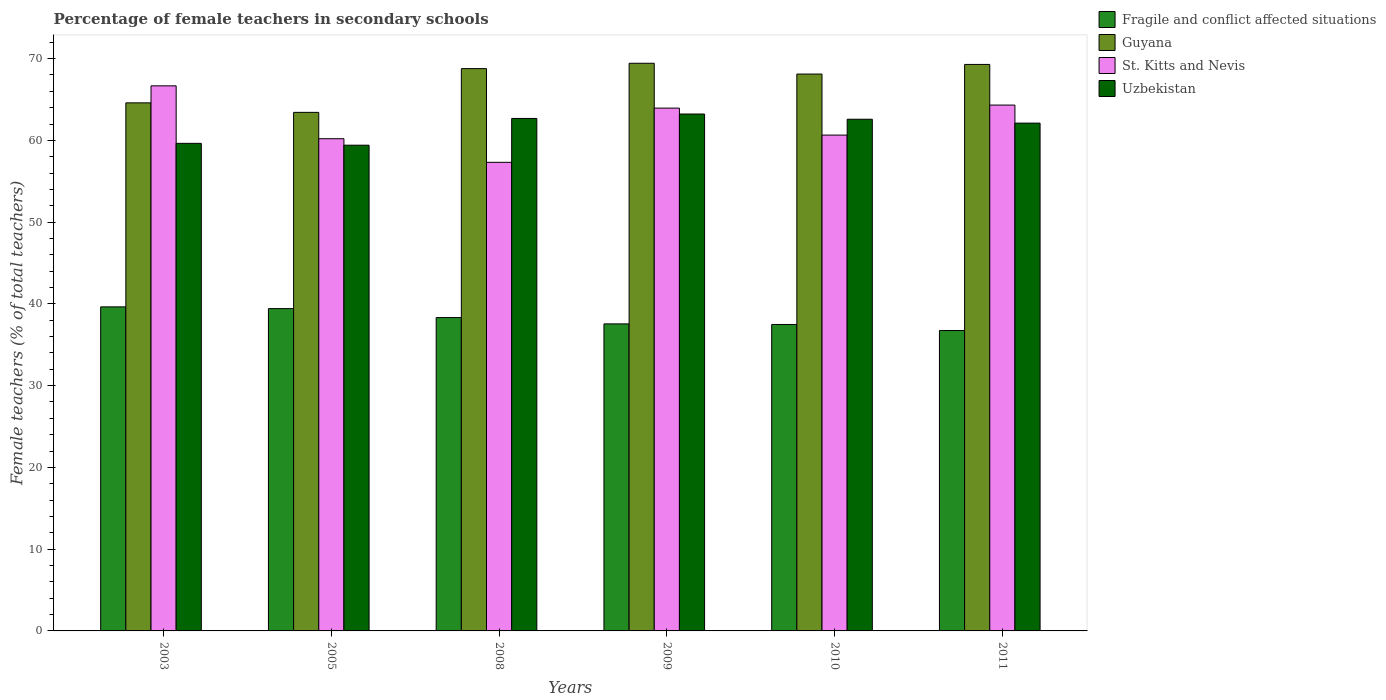How many groups of bars are there?
Your response must be concise. 6. Are the number of bars per tick equal to the number of legend labels?
Your response must be concise. Yes. Are the number of bars on each tick of the X-axis equal?
Provide a short and direct response. Yes. How many bars are there on the 3rd tick from the right?
Offer a very short reply. 4. What is the percentage of female teachers in St. Kitts and Nevis in 2008?
Make the answer very short. 57.31. Across all years, what is the maximum percentage of female teachers in Guyana?
Offer a terse response. 69.43. Across all years, what is the minimum percentage of female teachers in Fragile and conflict affected situations?
Your answer should be compact. 36.74. In which year was the percentage of female teachers in St. Kitts and Nevis minimum?
Keep it short and to the point. 2008. What is the total percentage of female teachers in St. Kitts and Nevis in the graph?
Provide a short and direct response. 373.09. What is the difference between the percentage of female teachers in St. Kitts and Nevis in 2005 and that in 2009?
Offer a very short reply. -3.74. What is the difference between the percentage of female teachers in Fragile and conflict affected situations in 2011 and the percentage of female teachers in St. Kitts and Nevis in 2008?
Your answer should be very brief. -20.57. What is the average percentage of female teachers in Fragile and conflict affected situations per year?
Provide a short and direct response. 38.19. In the year 2009, what is the difference between the percentage of female teachers in St. Kitts and Nevis and percentage of female teachers in Uzbekistan?
Provide a short and direct response. 0.73. In how many years, is the percentage of female teachers in Uzbekistan greater than 48 %?
Keep it short and to the point. 6. What is the ratio of the percentage of female teachers in Uzbekistan in 2003 to that in 2011?
Give a very brief answer. 0.96. Is the percentage of female teachers in Uzbekistan in 2003 less than that in 2009?
Your response must be concise. Yes. What is the difference between the highest and the second highest percentage of female teachers in Fragile and conflict affected situations?
Ensure brevity in your answer.  0.21. What is the difference between the highest and the lowest percentage of female teachers in St. Kitts and Nevis?
Your answer should be compact. 9.35. Is the sum of the percentage of female teachers in Guyana in 2005 and 2010 greater than the maximum percentage of female teachers in St. Kitts and Nevis across all years?
Offer a terse response. Yes. Is it the case that in every year, the sum of the percentage of female teachers in St. Kitts and Nevis and percentage of female teachers in Fragile and conflict affected situations is greater than the sum of percentage of female teachers in Uzbekistan and percentage of female teachers in Guyana?
Your answer should be very brief. No. What does the 2nd bar from the left in 2008 represents?
Your answer should be compact. Guyana. What does the 1st bar from the right in 2003 represents?
Make the answer very short. Uzbekistan. Is it the case that in every year, the sum of the percentage of female teachers in Guyana and percentage of female teachers in Fragile and conflict affected situations is greater than the percentage of female teachers in Uzbekistan?
Your answer should be very brief. Yes. Are all the bars in the graph horizontal?
Your answer should be compact. No. How many years are there in the graph?
Your answer should be compact. 6. Are the values on the major ticks of Y-axis written in scientific E-notation?
Make the answer very short. No. Does the graph contain grids?
Your answer should be very brief. No. How are the legend labels stacked?
Offer a very short reply. Vertical. What is the title of the graph?
Give a very brief answer. Percentage of female teachers in secondary schools. What is the label or title of the X-axis?
Your answer should be very brief. Years. What is the label or title of the Y-axis?
Your answer should be very brief. Female teachers (% of total teachers). What is the Female teachers (% of total teachers) of Fragile and conflict affected situations in 2003?
Offer a very short reply. 39.63. What is the Female teachers (% of total teachers) in Guyana in 2003?
Your answer should be compact. 64.59. What is the Female teachers (% of total teachers) in St. Kitts and Nevis in 2003?
Ensure brevity in your answer.  66.67. What is the Female teachers (% of total teachers) in Uzbekistan in 2003?
Make the answer very short. 59.63. What is the Female teachers (% of total teachers) of Fragile and conflict affected situations in 2005?
Ensure brevity in your answer.  39.42. What is the Female teachers (% of total teachers) of Guyana in 2005?
Give a very brief answer. 63.42. What is the Female teachers (% of total teachers) in St. Kitts and Nevis in 2005?
Offer a terse response. 60.2. What is the Female teachers (% of total teachers) in Uzbekistan in 2005?
Your response must be concise. 59.41. What is the Female teachers (% of total teachers) of Fragile and conflict affected situations in 2008?
Offer a very short reply. 38.33. What is the Female teachers (% of total teachers) of Guyana in 2008?
Provide a succinct answer. 68.77. What is the Female teachers (% of total teachers) in St. Kitts and Nevis in 2008?
Give a very brief answer. 57.31. What is the Female teachers (% of total teachers) in Uzbekistan in 2008?
Give a very brief answer. 62.68. What is the Female teachers (% of total teachers) of Fragile and conflict affected situations in 2009?
Your answer should be compact. 37.55. What is the Female teachers (% of total teachers) in Guyana in 2009?
Your response must be concise. 69.43. What is the Female teachers (% of total teachers) of St. Kitts and Nevis in 2009?
Offer a terse response. 63.95. What is the Female teachers (% of total teachers) in Uzbekistan in 2009?
Your answer should be very brief. 63.22. What is the Female teachers (% of total teachers) in Fragile and conflict affected situations in 2010?
Ensure brevity in your answer.  37.48. What is the Female teachers (% of total teachers) of Guyana in 2010?
Keep it short and to the point. 68.11. What is the Female teachers (% of total teachers) of St. Kitts and Nevis in 2010?
Ensure brevity in your answer.  60.65. What is the Female teachers (% of total teachers) of Uzbekistan in 2010?
Provide a succinct answer. 62.58. What is the Female teachers (% of total teachers) in Fragile and conflict affected situations in 2011?
Offer a terse response. 36.74. What is the Female teachers (% of total teachers) of Guyana in 2011?
Your answer should be very brief. 69.29. What is the Female teachers (% of total teachers) in St. Kitts and Nevis in 2011?
Keep it short and to the point. 64.32. What is the Female teachers (% of total teachers) in Uzbekistan in 2011?
Your response must be concise. 62.11. Across all years, what is the maximum Female teachers (% of total teachers) in Fragile and conflict affected situations?
Keep it short and to the point. 39.63. Across all years, what is the maximum Female teachers (% of total teachers) in Guyana?
Keep it short and to the point. 69.43. Across all years, what is the maximum Female teachers (% of total teachers) in St. Kitts and Nevis?
Give a very brief answer. 66.67. Across all years, what is the maximum Female teachers (% of total teachers) of Uzbekistan?
Ensure brevity in your answer.  63.22. Across all years, what is the minimum Female teachers (% of total teachers) in Fragile and conflict affected situations?
Your answer should be very brief. 36.74. Across all years, what is the minimum Female teachers (% of total teachers) of Guyana?
Provide a short and direct response. 63.42. Across all years, what is the minimum Female teachers (% of total teachers) in St. Kitts and Nevis?
Provide a succinct answer. 57.31. Across all years, what is the minimum Female teachers (% of total teachers) of Uzbekistan?
Make the answer very short. 59.41. What is the total Female teachers (% of total teachers) of Fragile and conflict affected situations in the graph?
Keep it short and to the point. 229.15. What is the total Female teachers (% of total teachers) in Guyana in the graph?
Make the answer very short. 403.61. What is the total Female teachers (% of total teachers) of St. Kitts and Nevis in the graph?
Your answer should be compact. 373.09. What is the total Female teachers (% of total teachers) in Uzbekistan in the graph?
Offer a very short reply. 369.63. What is the difference between the Female teachers (% of total teachers) of Fragile and conflict affected situations in 2003 and that in 2005?
Make the answer very short. 0.21. What is the difference between the Female teachers (% of total teachers) of Guyana in 2003 and that in 2005?
Make the answer very short. 1.16. What is the difference between the Female teachers (% of total teachers) in St. Kitts and Nevis in 2003 and that in 2005?
Your response must be concise. 6.47. What is the difference between the Female teachers (% of total teachers) in Uzbekistan in 2003 and that in 2005?
Give a very brief answer. 0.22. What is the difference between the Female teachers (% of total teachers) of Fragile and conflict affected situations in 2003 and that in 2008?
Your response must be concise. 1.31. What is the difference between the Female teachers (% of total teachers) of Guyana in 2003 and that in 2008?
Offer a very short reply. -4.19. What is the difference between the Female teachers (% of total teachers) of St. Kitts and Nevis in 2003 and that in 2008?
Ensure brevity in your answer.  9.35. What is the difference between the Female teachers (% of total teachers) of Uzbekistan in 2003 and that in 2008?
Make the answer very short. -3.04. What is the difference between the Female teachers (% of total teachers) of Fragile and conflict affected situations in 2003 and that in 2009?
Give a very brief answer. 2.08. What is the difference between the Female teachers (% of total teachers) in Guyana in 2003 and that in 2009?
Ensure brevity in your answer.  -4.84. What is the difference between the Female teachers (% of total teachers) of St. Kitts and Nevis in 2003 and that in 2009?
Your response must be concise. 2.72. What is the difference between the Female teachers (% of total teachers) of Uzbekistan in 2003 and that in 2009?
Your answer should be compact. -3.59. What is the difference between the Female teachers (% of total teachers) in Fragile and conflict affected situations in 2003 and that in 2010?
Your answer should be compact. 2.15. What is the difference between the Female teachers (% of total teachers) in Guyana in 2003 and that in 2010?
Offer a very short reply. -3.52. What is the difference between the Female teachers (% of total teachers) in St. Kitts and Nevis in 2003 and that in 2010?
Keep it short and to the point. 6.02. What is the difference between the Female teachers (% of total teachers) of Uzbekistan in 2003 and that in 2010?
Your answer should be very brief. -2.95. What is the difference between the Female teachers (% of total teachers) in Fragile and conflict affected situations in 2003 and that in 2011?
Give a very brief answer. 2.89. What is the difference between the Female teachers (% of total teachers) in Guyana in 2003 and that in 2011?
Your answer should be very brief. -4.7. What is the difference between the Female teachers (% of total teachers) of St. Kitts and Nevis in 2003 and that in 2011?
Offer a terse response. 2.35. What is the difference between the Female teachers (% of total teachers) in Uzbekistan in 2003 and that in 2011?
Keep it short and to the point. -2.47. What is the difference between the Female teachers (% of total teachers) of Fragile and conflict affected situations in 2005 and that in 2008?
Your answer should be compact. 1.09. What is the difference between the Female teachers (% of total teachers) in Guyana in 2005 and that in 2008?
Keep it short and to the point. -5.35. What is the difference between the Female teachers (% of total teachers) in St. Kitts and Nevis in 2005 and that in 2008?
Provide a succinct answer. 2.89. What is the difference between the Female teachers (% of total teachers) of Uzbekistan in 2005 and that in 2008?
Give a very brief answer. -3.27. What is the difference between the Female teachers (% of total teachers) in Fragile and conflict affected situations in 2005 and that in 2009?
Ensure brevity in your answer.  1.87. What is the difference between the Female teachers (% of total teachers) of Guyana in 2005 and that in 2009?
Your answer should be compact. -6.01. What is the difference between the Female teachers (% of total teachers) of St. Kitts and Nevis in 2005 and that in 2009?
Ensure brevity in your answer.  -3.74. What is the difference between the Female teachers (% of total teachers) in Uzbekistan in 2005 and that in 2009?
Make the answer very short. -3.81. What is the difference between the Female teachers (% of total teachers) in Fragile and conflict affected situations in 2005 and that in 2010?
Provide a succinct answer. 1.94. What is the difference between the Female teachers (% of total teachers) in Guyana in 2005 and that in 2010?
Keep it short and to the point. -4.69. What is the difference between the Female teachers (% of total teachers) of St. Kitts and Nevis in 2005 and that in 2010?
Make the answer very short. -0.44. What is the difference between the Female teachers (% of total teachers) in Uzbekistan in 2005 and that in 2010?
Your answer should be compact. -3.17. What is the difference between the Female teachers (% of total teachers) in Fragile and conflict affected situations in 2005 and that in 2011?
Your response must be concise. 2.68. What is the difference between the Female teachers (% of total teachers) in Guyana in 2005 and that in 2011?
Offer a terse response. -5.86. What is the difference between the Female teachers (% of total teachers) of St. Kitts and Nevis in 2005 and that in 2011?
Your answer should be compact. -4.11. What is the difference between the Female teachers (% of total teachers) in Uzbekistan in 2005 and that in 2011?
Your answer should be compact. -2.7. What is the difference between the Female teachers (% of total teachers) of Fragile and conflict affected situations in 2008 and that in 2009?
Keep it short and to the point. 0.77. What is the difference between the Female teachers (% of total teachers) of Guyana in 2008 and that in 2009?
Offer a very short reply. -0.66. What is the difference between the Female teachers (% of total teachers) of St. Kitts and Nevis in 2008 and that in 2009?
Offer a terse response. -6.63. What is the difference between the Female teachers (% of total teachers) in Uzbekistan in 2008 and that in 2009?
Provide a short and direct response. -0.54. What is the difference between the Female teachers (% of total teachers) in Fragile and conflict affected situations in 2008 and that in 2010?
Provide a short and direct response. 0.84. What is the difference between the Female teachers (% of total teachers) in Guyana in 2008 and that in 2010?
Your response must be concise. 0.67. What is the difference between the Female teachers (% of total teachers) of St. Kitts and Nevis in 2008 and that in 2010?
Your answer should be very brief. -3.33. What is the difference between the Female teachers (% of total teachers) in Uzbekistan in 2008 and that in 2010?
Make the answer very short. 0.09. What is the difference between the Female teachers (% of total teachers) of Fragile and conflict affected situations in 2008 and that in 2011?
Provide a succinct answer. 1.58. What is the difference between the Female teachers (% of total teachers) of Guyana in 2008 and that in 2011?
Your answer should be very brief. -0.51. What is the difference between the Female teachers (% of total teachers) of St. Kitts and Nevis in 2008 and that in 2011?
Make the answer very short. -7. What is the difference between the Female teachers (% of total teachers) of Uzbekistan in 2008 and that in 2011?
Your answer should be very brief. 0.57. What is the difference between the Female teachers (% of total teachers) of Fragile and conflict affected situations in 2009 and that in 2010?
Give a very brief answer. 0.07. What is the difference between the Female teachers (% of total teachers) of Guyana in 2009 and that in 2010?
Provide a short and direct response. 1.32. What is the difference between the Female teachers (% of total teachers) of St. Kitts and Nevis in 2009 and that in 2010?
Give a very brief answer. 3.3. What is the difference between the Female teachers (% of total teachers) in Uzbekistan in 2009 and that in 2010?
Ensure brevity in your answer.  0.64. What is the difference between the Female teachers (% of total teachers) in Fragile and conflict affected situations in 2009 and that in 2011?
Your answer should be very brief. 0.81. What is the difference between the Female teachers (% of total teachers) of Guyana in 2009 and that in 2011?
Your answer should be very brief. 0.14. What is the difference between the Female teachers (% of total teachers) of St. Kitts and Nevis in 2009 and that in 2011?
Give a very brief answer. -0.37. What is the difference between the Female teachers (% of total teachers) of Uzbekistan in 2009 and that in 2011?
Make the answer very short. 1.11. What is the difference between the Female teachers (% of total teachers) in Fragile and conflict affected situations in 2010 and that in 2011?
Provide a short and direct response. 0.74. What is the difference between the Female teachers (% of total teachers) in Guyana in 2010 and that in 2011?
Your answer should be compact. -1.18. What is the difference between the Female teachers (% of total teachers) in St. Kitts and Nevis in 2010 and that in 2011?
Keep it short and to the point. -3.67. What is the difference between the Female teachers (% of total teachers) in Uzbekistan in 2010 and that in 2011?
Give a very brief answer. 0.47. What is the difference between the Female teachers (% of total teachers) in Fragile and conflict affected situations in 2003 and the Female teachers (% of total teachers) in Guyana in 2005?
Offer a very short reply. -23.79. What is the difference between the Female teachers (% of total teachers) of Fragile and conflict affected situations in 2003 and the Female teachers (% of total teachers) of St. Kitts and Nevis in 2005?
Give a very brief answer. -20.57. What is the difference between the Female teachers (% of total teachers) in Fragile and conflict affected situations in 2003 and the Female teachers (% of total teachers) in Uzbekistan in 2005?
Provide a succinct answer. -19.77. What is the difference between the Female teachers (% of total teachers) in Guyana in 2003 and the Female teachers (% of total teachers) in St. Kitts and Nevis in 2005?
Offer a terse response. 4.38. What is the difference between the Female teachers (% of total teachers) in Guyana in 2003 and the Female teachers (% of total teachers) in Uzbekistan in 2005?
Make the answer very short. 5.18. What is the difference between the Female teachers (% of total teachers) of St. Kitts and Nevis in 2003 and the Female teachers (% of total teachers) of Uzbekistan in 2005?
Make the answer very short. 7.26. What is the difference between the Female teachers (% of total teachers) of Fragile and conflict affected situations in 2003 and the Female teachers (% of total teachers) of Guyana in 2008?
Make the answer very short. -29.14. What is the difference between the Female teachers (% of total teachers) in Fragile and conflict affected situations in 2003 and the Female teachers (% of total teachers) in St. Kitts and Nevis in 2008?
Ensure brevity in your answer.  -17.68. What is the difference between the Female teachers (% of total teachers) in Fragile and conflict affected situations in 2003 and the Female teachers (% of total teachers) in Uzbekistan in 2008?
Your answer should be very brief. -23.04. What is the difference between the Female teachers (% of total teachers) of Guyana in 2003 and the Female teachers (% of total teachers) of St. Kitts and Nevis in 2008?
Ensure brevity in your answer.  7.27. What is the difference between the Female teachers (% of total teachers) in Guyana in 2003 and the Female teachers (% of total teachers) in Uzbekistan in 2008?
Offer a very short reply. 1.91. What is the difference between the Female teachers (% of total teachers) in St. Kitts and Nevis in 2003 and the Female teachers (% of total teachers) in Uzbekistan in 2008?
Make the answer very short. 3.99. What is the difference between the Female teachers (% of total teachers) of Fragile and conflict affected situations in 2003 and the Female teachers (% of total teachers) of Guyana in 2009?
Keep it short and to the point. -29.8. What is the difference between the Female teachers (% of total teachers) in Fragile and conflict affected situations in 2003 and the Female teachers (% of total teachers) in St. Kitts and Nevis in 2009?
Provide a short and direct response. -24.31. What is the difference between the Female teachers (% of total teachers) of Fragile and conflict affected situations in 2003 and the Female teachers (% of total teachers) of Uzbekistan in 2009?
Give a very brief answer. -23.59. What is the difference between the Female teachers (% of total teachers) of Guyana in 2003 and the Female teachers (% of total teachers) of St. Kitts and Nevis in 2009?
Provide a succinct answer. 0.64. What is the difference between the Female teachers (% of total teachers) in Guyana in 2003 and the Female teachers (% of total teachers) in Uzbekistan in 2009?
Give a very brief answer. 1.37. What is the difference between the Female teachers (% of total teachers) in St. Kitts and Nevis in 2003 and the Female teachers (% of total teachers) in Uzbekistan in 2009?
Make the answer very short. 3.45. What is the difference between the Female teachers (% of total teachers) in Fragile and conflict affected situations in 2003 and the Female teachers (% of total teachers) in Guyana in 2010?
Your response must be concise. -28.48. What is the difference between the Female teachers (% of total teachers) in Fragile and conflict affected situations in 2003 and the Female teachers (% of total teachers) in St. Kitts and Nevis in 2010?
Ensure brevity in your answer.  -21.01. What is the difference between the Female teachers (% of total teachers) in Fragile and conflict affected situations in 2003 and the Female teachers (% of total teachers) in Uzbekistan in 2010?
Keep it short and to the point. -22.95. What is the difference between the Female teachers (% of total teachers) of Guyana in 2003 and the Female teachers (% of total teachers) of St. Kitts and Nevis in 2010?
Provide a succinct answer. 3.94. What is the difference between the Female teachers (% of total teachers) in Guyana in 2003 and the Female teachers (% of total teachers) in Uzbekistan in 2010?
Provide a short and direct response. 2. What is the difference between the Female teachers (% of total teachers) of St. Kitts and Nevis in 2003 and the Female teachers (% of total teachers) of Uzbekistan in 2010?
Your answer should be compact. 4.08. What is the difference between the Female teachers (% of total teachers) in Fragile and conflict affected situations in 2003 and the Female teachers (% of total teachers) in Guyana in 2011?
Keep it short and to the point. -29.65. What is the difference between the Female teachers (% of total teachers) of Fragile and conflict affected situations in 2003 and the Female teachers (% of total teachers) of St. Kitts and Nevis in 2011?
Your answer should be very brief. -24.68. What is the difference between the Female teachers (% of total teachers) of Fragile and conflict affected situations in 2003 and the Female teachers (% of total teachers) of Uzbekistan in 2011?
Offer a terse response. -22.47. What is the difference between the Female teachers (% of total teachers) in Guyana in 2003 and the Female teachers (% of total teachers) in St. Kitts and Nevis in 2011?
Your answer should be very brief. 0.27. What is the difference between the Female teachers (% of total teachers) of Guyana in 2003 and the Female teachers (% of total teachers) of Uzbekistan in 2011?
Your answer should be compact. 2.48. What is the difference between the Female teachers (% of total teachers) of St. Kitts and Nevis in 2003 and the Female teachers (% of total teachers) of Uzbekistan in 2011?
Your answer should be very brief. 4.56. What is the difference between the Female teachers (% of total teachers) of Fragile and conflict affected situations in 2005 and the Female teachers (% of total teachers) of Guyana in 2008?
Give a very brief answer. -29.35. What is the difference between the Female teachers (% of total teachers) of Fragile and conflict affected situations in 2005 and the Female teachers (% of total teachers) of St. Kitts and Nevis in 2008?
Offer a terse response. -17.89. What is the difference between the Female teachers (% of total teachers) of Fragile and conflict affected situations in 2005 and the Female teachers (% of total teachers) of Uzbekistan in 2008?
Provide a succinct answer. -23.26. What is the difference between the Female teachers (% of total teachers) of Guyana in 2005 and the Female teachers (% of total teachers) of St. Kitts and Nevis in 2008?
Give a very brief answer. 6.11. What is the difference between the Female teachers (% of total teachers) of Guyana in 2005 and the Female teachers (% of total teachers) of Uzbekistan in 2008?
Provide a short and direct response. 0.75. What is the difference between the Female teachers (% of total teachers) in St. Kitts and Nevis in 2005 and the Female teachers (% of total teachers) in Uzbekistan in 2008?
Give a very brief answer. -2.48. What is the difference between the Female teachers (% of total teachers) of Fragile and conflict affected situations in 2005 and the Female teachers (% of total teachers) of Guyana in 2009?
Keep it short and to the point. -30.01. What is the difference between the Female teachers (% of total teachers) in Fragile and conflict affected situations in 2005 and the Female teachers (% of total teachers) in St. Kitts and Nevis in 2009?
Make the answer very short. -24.52. What is the difference between the Female teachers (% of total teachers) in Fragile and conflict affected situations in 2005 and the Female teachers (% of total teachers) in Uzbekistan in 2009?
Your answer should be very brief. -23.8. What is the difference between the Female teachers (% of total teachers) in Guyana in 2005 and the Female teachers (% of total teachers) in St. Kitts and Nevis in 2009?
Your answer should be very brief. -0.52. What is the difference between the Female teachers (% of total teachers) in Guyana in 2005 and the Female teachers (% of total teachers) in Uzbekistan in 2009?
Your answer should be compact. 0.2. What is the difference between the Female teachers (% of total teachers) in St. Kitts and Nevis in 2005 and the Female teachers (% of total teachers) in Uzbekistan in 2009?
Make the answer very short. -3.02. What is the difference between the Female teachers (% of total teachers) of Fragile and conflict affected situations in 2005 and the Female teachers (% of total teachers) of Guyana in 2010?
Provide a short and direct response. -28.69. What is the difference between the Female teachers (% of total teachers) in Fragile and conflict affected situations in 2005 and the Female teachers (% of total teachers) in St. Kitts and Nevis in 2010?
Your answer should be very brief. -21.22. What is the difference between the Female teachers (% of total teachers) in Fragile and conflict affected situations in 2005 and the Female teachers (% of total teachers) in Uzbekistan in 2010?
Keep it short and to the point. -23.16. What is the difference between the Female teachers (% of total teachers) of Guyana in 2005 and the Female teachers (% of total teachers) of St. Kitts and Nevis in 2010?
Provide a short and direct response. 2.78. What is the difference between the Female teachers (% of total teachers) of Guyana in 2005 and the Female teachers (% of total teachers) of Uzbekistan in 2010?
Your response must be concise. 0.84. What is the difference between the Female teachers (% of total teachers) in St. Kitts and Nevis in 2005 and the Female teachers (% of total teachers) in Uzbekistan in 2010?
Provide a succinct answer. -2.38. What is the difference between the Female teachers (% of total teachers) of Fragile and conflict affected situations in 2005 and the Female teachers (% of total teachers) of Guyana in 2011?
Your answer should be compact. -29.87. What is the difference between the Female teachers (% of total teachers) of Fragile and conflict affected situations in 2005 and the Female teachers (% of total teachers) of St. Kitts and Nevis in 2011?
Provide a short and direct response. -24.9. What is the difference between the Female teachers (% of total teachers) in Fragile and conflict affected situations in 2005 and the Female teachers (% of total teachers) in Uzbekistan in 2011?
Your response must be concise. -22.69. What is the difference between the Female teachers (% of total teachers) of Guyana in 2005 and the Female teachers (% of total teachers) of St. Kitts and Nevis in 2011?
Offer a terse response. -0.89. What is the difference between the Female teachers (% of total teachers) in Guyana in 2005 and the Female teachers (% of total teachers) in Uzbekistan in 2011?
Offer a terse response. 1.31. What is the difference between the Female teachers (% of total teachers) of St. Kitts and Nevis in 2005 and the Female teachers (% of total teachers) of Uzbekistan in 2011?
Your answer should be compact. -1.91. What is the difference between the Female teachers (% of total teachers) of Fragile and conflict affected situations in 2008 and the Female teachers (% of total teachers) of Guyana in 2009?
Ensure brevity in your answer.  -31.1. What is the difference between the Female teachers (% of total teachers) of Fragile and conflict affected situations in 2008 and the Female teachers (% of total teachers) of St. Kitts and Nevis in 2009?
Ensure brevity in your answer.  -25.62. What is the difference between the Female teachers (% of total teachers) of Fragile and conflict affected situations in 2008 and the Female teachers (% of total teachers) of Uzbekistan in 2009?
Ensure brevity in your answer.  -24.89. What is the difference between the Female teachers (% of total teachers) of Guyana in 2008 and the Female teachers (% of total teachers) of St. Kitts and Nevis in 2009?
Ensure brevity in your answer.  4.83. What is the difference between the Female teachers (% of total teachers) in Guyana in 2008 and the Female teachers (% of total teachers) in Uzbekistan in 2009?
Make the answer very short. 5.55. What is the difference between the Female teachers (% of total teachers) in St. Kitts and Nevis in 2008 and the Female teachers (% of total teachers) in Uzbekistan in 2009?
Offer a very short reply. -5.91. What is the difference between the Female teachers (% of total teachers) in Fragile and conflict affected situations in 2008 and the Female teachers (% of total teachers) in Guyana in 2010?
Make the answer very short. -29.78. What is the difference between the Female teachers (% of total teachers) in Fragile and conflict affected situations in 2008 and the Female teachers (% of total teachers) in St. Kitts and Nevis in 2010?
Keep it short and to the point. -22.32. What is the difference between the Female teachers (% of total teachers) of Fragile and conflict affected situations in 2008 and the Female teachers (% of total teachers) of Uzbekistan in 2010?
Your response must be concise. -24.26. What is the difference between the Female teachers (% of total teachers) in Guyana in 2008 and the Female teachers (% of total teachers) in St. Kitts and Nevis in 2010?
Offer a terse response. 8.13. What is the difference between the Female teachers (% of total teachers) in Guyana in 2008 and the Female teachers (% of total teachers) in Uzbekistan in 2010?
Offer a very short reply. 6.19. What is the difference between the Female teachers (% of total teachers) of St. Kitts and Nevis in 2008 and the Female teachers (% of total teachers) of Uzbekistan in 2010?
Provide a short and direct response. -5.27. What is the difference between the Female teachers (% of total teachers) of Fragile and conflict affected situations in 2008 and the Female teachers (% of total teachers) of Guyana in 2011?
Your answer should be very brief. -30.96. What is the difference between the Female teachers (% of total teachers) of Fragile and conflict affected situations in 2008 and the Female teachers (% of total teachers) of St. Kitts and Nevis in 2011?
Your answer should be very brief. -25.99. What is the difference between the Female teachers (% of total teachers) of Fragile and conflict affected situations in 2008 and the Female teachers (% of total teachers) of Uzbekistan in 2011?
Give a very brief answer. -23.78. What is the difference between the Female teachers (% of total teachers) of Guyana in 2008 and the Female teachers (% of total teachers) of St. Kitts and Nevis in 2011?
Your answer should be very brief. 4.46. What is the difference between the Female teachers (% of total teachers) of Guyana in 2008 and the Female teachers (% of total teachers) of Uzbekistan in 2011?
Your response must be concise. 6.67. What is the difference between the Female teachers (% of total teachers) in St. Kitts and Nevis in 2008 and the Female teachers (% of total teachers) in Uzbekistan in 2011?
Your answer should be very brief. -4.79. What is the difference between the Female teachers (% of total teachers) of Fragile and conflict affected situations in 2009 and the Female teachers (% of total teachers) of Guyana in 2010?
Offer a very short reply. -30.56. What is the difference between the Female teachers (% of total teachers) of Fragile and conflict affected situations in 2009 and the Female teachers (% of total teachers) of St. Kitts and Nevis in 2010?
Your response must be concise. -23.09. What is the difference between the Female teachers (% of total teachers) of Fragile and conflict affected situations in 2009 and the Female teachers (% of total teachers) of Uzbekistan in 2010?
Offer a terse response. -25.03. What is the difference between the Female teachers (% of total teachers) in Guyana in 2009 and the Female teachers (% of total teachers) in St. Kitts and Nevis in 2010?
Your response must be concise. 8.78. What is the difference between the Female teachers (% of total teachers) in Guyana in 2009 and the Female teachers (% of total teachers) in Uzbekistan in 2010?
Keep it short and to the point. 6.85. What is the difference between the Female teachers (% of total teachers) of St. Kitts and Nevis in 2009 and the Female teachers (% of total teachers) of Uzbekistan in 2010?
Keep it short and to the point. 1.36. What is the difference between the Female teachers (% of total teachers) of Fragile and conflict affected situations in 2009 and the Female teachers (% of total teachers) of Guyana in 2011?
Your response must be concise. -31.73. What is the difference between the Female teachers (% of total teachers) of Fragile and conflict affected situations in 2009 and the Female teachers (% of total teachers) of St. Kitts and Nevis in 2011?
Your answer should be compact. -26.76. What is the difference between the Female teachers (% of total teachers) of Fragile and conflict affected situations in 2009 and the Female teachers (% of total teachers) of Uzbekistan in 2011?
Ensure brevity in your answer.  -24.56. What is the difference between the Female teachers (% of total teachers) of Guyana in 2009 and the Female teachers (% of total teachers) of St. Kitts and Nevis in 2011?
Your answer should be very brief. 5.11. What is the difference between the Female teachers (% of total teachers) of Guyana in 2009 and the Female teachers (% of total teachers) of Uzbekistan in 2011?
Offer a very short reply. 7.32. What is the difference between the Female teachers (% of total teachers) of St. Kitts and Nevis in 2009 and the Female teachers (% of total teachers) of Uzbekistan in 2011?
Your response must be concise. 1.84. What is the difference between the Female teachers (% of total teachers) of Fragile and conflict affected situations in 2010 and the Female teachers (% of total teachers) of Guyana in 2011?
Your answer should be very brief. -31.81. What is the difference between the Female teachers (% of total teachers) of Fragile and conflict affected situations in 2010 and the Female teachers (% of total teachers) of St. Kitts and Nevis in 2011?
Provide a short and direct response. -26.84. What is the difference between the Female teachers (% of total teachers) of Fragile and conflict affected situations in 2010 and the Female teachers (% of total teachers) of Uzbekistan in 2011?
Provide a succinct answer. -24.63. What is the difference between the Female teachers (% of total teachers) of Guyana in 2010 and the Female teachers (% of total teachers) of St. Kitts and Nevis in 2011?
Provide a short and direct response. 3.79. What is the difference between the Female teachers (% of total teachers) of Guyana in 2010 and the Female teachers (% of total teachers) of Uzbekistan in 2011?
Your answer should be very brief. 6. What is the difference between the Female teachers (% of total teachers) of St. Kitts and Nevis in 2010 and the Female teachers (% of total teachers) of Uzbekistan in 2011?
Give a very brief answer. -1.46. What is the average Female teachers (% of total teachers) in Fragile and conflict affected situations per year?
Ensure brevity in your answer.  38.19. What is the average Female teachers (% of total teachers) in Guyana per year?
Keep it short and to the point. 67.27. What is the average Female teachers (% of total teachers) in St. Kitts and Nevis per year?
Your answer should be very brief. 62.18. What is the average Female teachers (% of total teachers) in Uzbekistan per year?
Your answer should be very brief. 61.6. In the year 2003, what is the difference between the Female teachers (% of total teachers) in Fragile and conflict affected situations and Female teachers (% of total teachers) in Guyana?
Keep it short and to the point. -24.95. In the year 2003, what is the difference between the Female teachers (% of total teachers) of Fragile and conflict affected situations and Female teachers (% of total teachers) of St. Kitts and Nevis?
Make the answer very short. -27.03. In the year 2003, what is the difference between the Female teachers (% of total teachers) in Fragile and conflict affected situations and Female teachers (% of total teachers) in Uzbekistan?
Offer a terse response. -20. In the year 2003, what is the difference between the Female teachers (% of total teachers) of Guyana and Female teachers (% of total teachers) of St. Kitts and Nevis?
Your response must be concise. -2.08. In the year 2003, what is the difference between the Female teachers (% of total teachers) of Guyana and Female teachers (% of total teachers) of Uzbekistan?
Provide a short and direct response. 4.95. In the year 2003, what is the difference between the Female teachers (% of total teachers) in St. Kitts and Nevis and Female teachers (% of total teachers) in Uzbekistan?
Your answer should be compact. 7.03. In the year 2005, what is the difference between the Female teachers (% of total teachers) of Fragile and conflict affected situations and Female teachers (% of total teachers) of Guyana?
Your answer should be compact. -24. In the year 2005, what is the difference between the Female teachers (% of total teachers) of Fragile and conflict affected situations and Female teachers (% of total teachers) of St. Kitts and Nevis?
Provide a short and direct response. -20.78. In the year 2005, what is the difference between the Female teachers (% of total teachers) in Fragile and conflict affected situations and Female teachers (% of total teachers) in Uzbekistan?
Offer a terse response. -19.99. In the year 2005, what is the difference between the Female teachers (% of total teachers) in Guyana and Female teachers (% of total teachers) in St. Kitts and Nevis?
Your answer should be very brief. 3.22. In the year 2005, what is the difference between the Female teachers (% of total teachers) of Guyana and Female teachers (% of total teachers) of Uzbekistan?
Give a very brief answer. 4.01. In the year 2005, what is the difference between the Female teachers (% of total teachers) in St. Kitts and Nevis and Female teachers (% of total teachers) in Uzbekistan?
Offer a very short reply. 0.79. In the year 2008, what is the difference between the Female teachers (% of total teachers) of Fragile and conflict affected situations and Female teachers (% of total teachers) of Guyana?
Provide a succinct answer. -30.45. In the year 2008, what is the difference between the Female teachers (% of total teachers) of Fragile and conflict affected situations and Female teachers (% of total teachers) of St. Kitts and Nevis?
Your response must be concise. -18.99. In the year 2008, what is the difference between the Female teachers (% of total teachers) in Fragile and conflict affected situations and Female teachers (% of total teachers) in Uzbekistan?
Ensure brevity in your answer.  -24.35. In the year 2008, what is the difference between the Female teachers (% of total teachers) in Guyana and Female teachers (% of total teachers) in St. Kitts and Nevis?
Provide a short and direct response. 11.46. In the year 2008, what is the difference between the Female teachers (% of total teachers) in Guyana and Female teachers (% of total teachers) in Uzbekistan?
Provide a succinct answer. 6.1. In the year 2008, what is the difference between the Female teachers (% of total teachers) of St. Kitts and Nevis and Female teachers (% of total teachers) of Uzbekistan?
Your answer should be compact. -5.36. In the year 2009, what is the difference between the Female teachers (% of total teachers) of Fragile and conflict affected situations and Female teachers (% of total teachers) of Guyana?
Keep it short and to the point. -31.88. In the year 2009, what is the difference between the Female teachers (% of total teachers) in Fragile and conflict affected situations and Female teachers (% of total teachers) in St. Kitts and Nevis?
Your response must be concise. -26.39. In the year 2009, what is the difference between the Female teachers (% of total teachers) of Fragile and conflict affected situations and Female teachers (% of total teachers) of Uzbekistan?
Make the answer very short. -25.67. In the year 2009, what is the difference between the Female teachers (% of total teachers) in Guyana and Female teachers (% of total teachers) in St. Kitts and Nevis?
Offer a terse response. 5.48. In the year 2009, what is the difference between the Female teachers (% of total teachers) of Guyana and Female teachers (% of total teachers) of Uzbekistan?
Offer a terse response. 6.21. In the year 2009, what is the difference between the Female teachers (% of total teachers) of St. Kitts and Nevis and Female teachers (% of total teachers) of Uzbekistan?
Offer a very short reply. 0.72. In the year 2010, what is the difference between the Female teachers (% of total teachers) in Fragile and conflict affected situations and Female teachers (% of total teachers) in Guyana?
Provide a succinct answer. -30.63. In the year 2010, what is the difference between the Female teachers (% of total teachers) of Fragile and conflict affected situations and Female teachers (% of total teachers) of St. Kitts and Nevis?
Your answer should be compact. -23.16. In the year 2010, what is the difference between the Female teachers (% of total teachers) of Fragile and conflict affected situations and Female teachers (% of total teachers) of Uzbekistan?
Your response must be concise. -25.1. In the year 2010, what is the difference between the Female teachers (% of total teachers) of Guyana and Female teachers (% of total teachers) of St. Kitts and Nevis?
Provide a succinct answer. 7.46. In the year 2010, what is the difference between the Female teachers (% of total teachers) in Guyana and Female teachers (% of total teachers) in Uzbekistan?
Give a very brief answer. 5.53. In the year 2010, what is the difference between the Female teachers (% of total teachers) of St. Kitts and Nevis and Female teachers (% of total teachers) of Uzbekistan?
Provide a short and direct response. -1.94. In the year 2011, what is the difference between the Female teachers (% of total teachers) in Fragile and conflict affected situations and Female teachers (% of total teachers) in Guyana?
Provide a short and direct response. -32.55. In the year 2011, what is the difference between the Female teachers (% of total teachers) of Fragile and conflict affected situations and Female teachers (% of total teachers) of St. Kitts and Nevis?
Give a very brief answer. -27.57. In the year 2011, what is the difference between the Female teachers (% of total teachers) in Fragile and conflict affected situations and Female teachers (% of total teachers) in Uzbekistan?
Your answer should be compact. -25.37. In the year 2011, what is the difference between the Female teachers (% of total teachers) of Guyana and Female teachers (% of total teachers) of St. Kitts and Nevis?
Make the answer very short. 4.97. In the year 2011, what is the difference between the Female teachers (% of total teachers) in Guyana and Female teachers (% of total teachers) in Uzbekistan?
Keep it short and to the point. 7.18. In the year 2011, what is the difference between the Female teachers (% of total teachers) in St. Kitts and Nevis and Female teachers (% of total teachers) in Uzbekistan?
Give a very brief answer. 2.21. What is the ratio of the Female teachers (% of total teachers) in Fragile and conflict affected situations in 2003 to that in 2005?
Ensure brevity in your answer.  1.01. What is the ratio of the Female teachers (% of total teachers) in Guyana in 2003 to that in 2005?
Offer a very short reply. 1.02. What is the ratio of the Female teachers (% of total teachers) in St. Kitts and Nevis in 2003 to that in 2005?
Offer a terse response. 1.11. What is the ratio of the Female teachers (% of total teachers) of Fragile and conflict affected situations in 2003 to that in 2008?
Your response must be concise. 1.03. What is the ratio of the Female teachers (% of total teachers) of Guyana in 2003 to that in 2008?
Provide a short and direct response. 0.94. What is the ratio of the Female teachers (% of total teachers) in St. Kitts and Nevis in 2003 to that in 2008?
Keep it short and to the point. 1.16. What is the ratio of the Female teachers (% of total teachers) of Uzbekistan in 2003 to that in 2008?
Make the answer very short. 0.95. What is the ratio of the Female teachers (% of total teachers) in Fragile and conflict affected situations in 2003 to that in 2009?
Ensure brevity in your answer.  1.06. What is the ratio of the Female teachers (% of total teachers) in Guyana in 2003 to that in 2009?
Ensure brevity in your answer.  0.93. What is the ratio of the Female teachers (% of total teachers) in St. Kitts and Nevis in 2003 to that in 2009?
Your answer should be compact. 1.04. What is the ratio of the Female teachers (% of total teachers) of Uzbekistan in 2003 to that in 2009?
Ensure brevity in your answer.  0.94. What is the ratio of the Female teachers (% of total teachers) of Fragile and conflict affected situations in 2003 to that in 2010?
Ensure brevity in your answer.  1.06. What is the ratio of the Female teachers (% of total teachers) in Guyana in 2003 to that in 2010?
Offer a very short reply. 0.95. What is the ratio of the Female teachers (% of total teachers) of St. Kitts and Nevis in 2003 to that in 2010?
Give a very brief answer. 1.1. What is the ratio of the Female teachers (% of total teachers) in Uzbekistan in 2003 to that in 2010?
Make the answer very short. 0.95. What is the ratio of the Female teachers (% of total teachers) of Fragile and conflict affected situations in 2003 to that in 2011?
Your answer should be very brief. 1.08. What is the ratio of the Female teachers (% of total teachers) of Guyana in 2003 to that in 2011?
Your response must be concise. 0.93. What is the ratio of the Female teachers (% of total teachers) in St. Kitts and Nevis in 2003 to that in 2011?
Provide a short and direct response. 1.04. What is the ratio of the Female teachers (% of total teachers) of Uzbekistan in 2003 to that in 2011?
Offer a terse response. 0.96. What is the ratio of the Female teachers (% of total teachers) of Fragile and conflict affected situations in 2005 to that in 2008?
Your answer should be compact. 1.03. What is the ratio of the Female teachers (% of total teachers) of Guyana in 2005 to that in 2008?
Make the answer very short. 0.92. What is the ratio of the Female teachers (% of total teachers) of St. Kitts and Nevis in 2005 to that in 2008?
Give a very brief answer. 1.05. What is the ratio of the Female teachers (% of total teachers) of Uzbekistan in 2005 to that in 2008?
Give a very brief answer. 0.95. What is the ratio of the Female teachers (% of total teachers) in Fragile and conflict affected situations in 2005 to that in 2009?
Give a very brief answer. 1.05. What is the ratio of the Female teachers (% of total teachers) of Guyana in 2005 to that in 2009?
Your answer should be very brief. 0.91. What is the ratio of the Female teachers (% of total teachers) in St. Kitts and Nevis in 2005 to that in 2009?
Provide a short and direct response. 0.94. What is the ratio of the Female teachers (% of total teachers) of Uzbekistan in 2005 to that in 2009?
Keep it short and to the point. 0.94. What is the ratio of the Female teachers (% of total teachers) in Fragile and conflict affected situations in 2005 to that in 2010?
Make the answer very short. 1.05. What is the ratio of the Female teachers (% of total teachers) in Guyana in 2005 to that in 2010?
Make the answer very short. 0.93. What is the ratio of the Female teachers (% of total teachers) of St. Kitts and Nevis in 2005 to that in 2010?
Your response must be concise. 0.99. What is the ratio of the Female teachers (% of total teachers) in Uzbekistan in 2005 to that in 2010?
Provide a succinct answer. 0.95. What is the ratio of the Female teachers (% of total teachers) of Fragile and conflict affected situations in 2005 to that in 2011?
Provide a short and direct response. 1.07. What is the ratio of the Female teachers (% of total teachers) in Guyana in 2005 to that in 2011?
Keep it short and to the point. 0.92. What is the ratio of the Female teachers (% of total teachers) of St. Kitts and Nevis in 2005 to that in 2011?
Offer a terse response. 0.94. What is the ratio of the Female teachers (% of total teachers) of Uzbekistan in 2005 to that in 2011?
Give a very brief answer. 0.96. What is the ratio of the Female teachers (% of total teachers) in Fragile and conflict affected situations in 2008 to that in 2009?
Your answer should be very brief. 1.02. What is the ratio of the Female teachers (% of total teachers) of Guyana in 2008 to that in 2009?
Give a very brief answer. 0.99. What is the ratio of the Female teachers (% of total teachers) in St. Kitts and Nevis in 2008 to that in 2009?
Make the answer very short. 0.9. What is the ratio of the Female teachers (% of total teachers) in Fragile and conflict affected situations in 2008 to that in 2010?
Provide a short and direct response. 1.02. What is the ratio of the Female teachers (% of total teachers) in Guyana in 2008 to that in 2010?
Provide a short and direct response. 1.01. What is the ratio of the Female teachers (% of total teachers) in St. Kitts and Nevis in 2008 to that in 2010?
Your answer should be very brief. 0.95. What is the ratio of the Female teachers (% of total teachers) of Fragile and conflict affected situations in 2008 to that in 2011?
Your response must be concise. 1.04. What is the ratio of the Female teachers (% of total teachers) in Guyana in 2008 to that in 2011?
Your response must be concise. 0.99. What is the ratio of the Female teachers (% of total teachers) of St. Kitts and Nevis in 2008 to that in 2011?
Offer a very short reply. 0.89. What is the ratio of the Female teachers (% of total teachers) of Uzbekistan in 2008 to that in 2011?
Keep it short and to the point. 1.01. What is the ratio of the Female teachers (% of total teachers) in Fragile and conflict affected situations in 2009 to that in 2010?
Provide a succinct answer. 1. What is the ratio of the Female teachers (% of total teachers) in Guyana in 2009 to that in 2010?
Offer a very short reply. 1.02. What is the ratio of the Female teachers (% of total teachers) in St. Kitts and Nevis in 2009 to that in 2010?
Offer a very short reply. 1.05. What is the ratio of the Female teachers (% of total teachers) of Uzbekistan in 2009 to that in 2010?
Make the answer very short. 1.01. What is the ratio of the Female teachers (% of total teachers) of Fragile and conflict affected situations in 2009 to that in 2011?
Give a very brief answer. 1.02. What is the ratio of the Female teachers (% of total teachers) of St. Kitts and Nevis in 2009 to that in 2011?
Provide a succinct answer. 0.99. What is the ratio of the Female teachers (% of total teachers) of Uzbekistan in 2009 to that in 2011?
Ensure brevity in your answer.  1.02. What is the ratio of the Female teachers (% of total teachers) in Fragile and conflict affected situations in 2010 to that in 2011?
Offer a terse response. 1.02. What is the ratio of the Female teachers (% of total teachers) in St. Kitts and Nevis in 2010 to that in 2011?
Make the answer very short. 0.94. What is the ratio of the Female teachers (% of total teachers) of Uzbekistan in 2010 to that in 2011?
Offer a terse response. 1.01. What is the difference between the highest and the second highest Female teachers (% of total teachers) of Fragile and conflict affected situations?
Ensure brevity in your answer.  0.21. What is the difference between the highest and the second highest Female teachers (% of total teachers) in Guyana?
Provide a succinct answer. 0.14. What is the difference between the highest and the second highest Female teachers (% of total teachers) of St. Kitts and Nevis?
Provide a short and direct response. 2.35. What is the difference between the highest and the second highest Female teachers (% of total teachers) in Uzbekistan?
Your answer should be very brief. 0.54. What is the difference between the highest and the lowest Female teachers (% of total teachers) in Fragile and conflict affected situations?
Provide a succinct answer. 2.89. What is the difference between the highest and the lowest Female teachers (% of total teachers) in Guyana?
Make the answer very short. 6.01. What is the difference between the highest and the lowest Female teachers (% of total teachers) in St. Kitts and Nevis?
Your answer should be very brief. 9.35. What is the difference between the highest and the lowest Female teachers (% of total teachers) of Uzbekistan?
Your response must be concise. 3.81. 